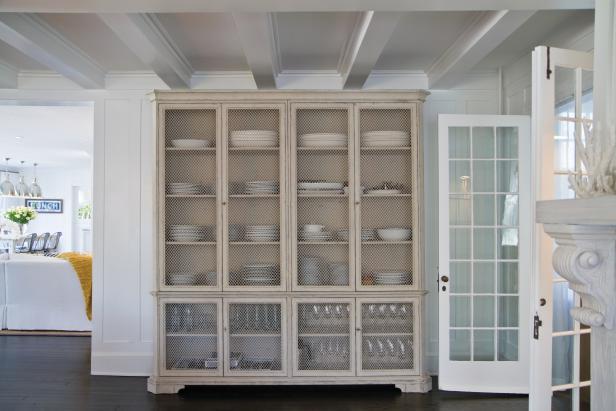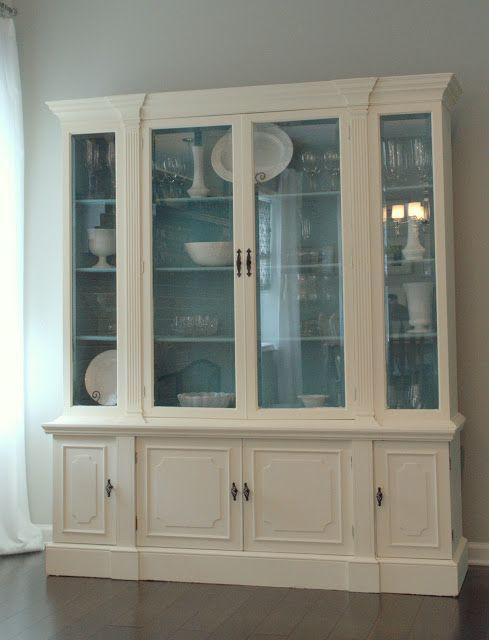The first image is the image on the left, the second image is the image on the right. Examine the images to the left and right. Is the description "There are cabinets with rounded tops" accurate? Answer yes or no. No. The first image is the image on the left, the second image is the image on the right. Analyze the images presented: Is the assertion "All cabinets pictured have flat tops, and the right-hand cabinet sits flush on the floor without legs." valid? Answer yes or no. Yes. 